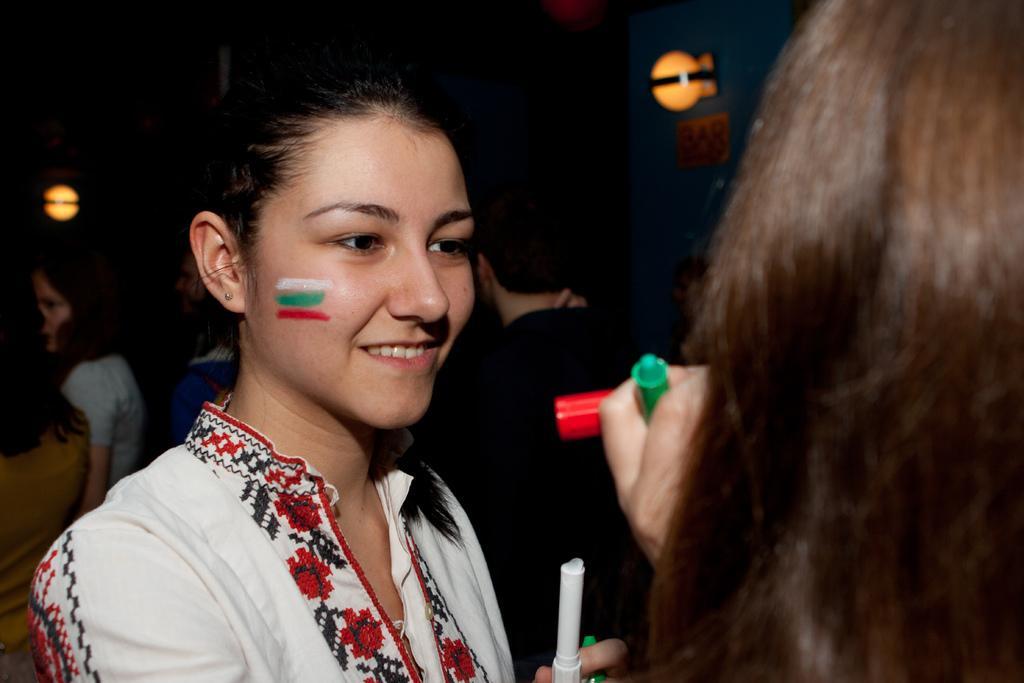In one or two sentences, can you explain what this image depicts? In this image we can see a woman and she is holding an object. There is a dark background and we can see lights, board, and people. On the right side of the image we can see person's hair. 